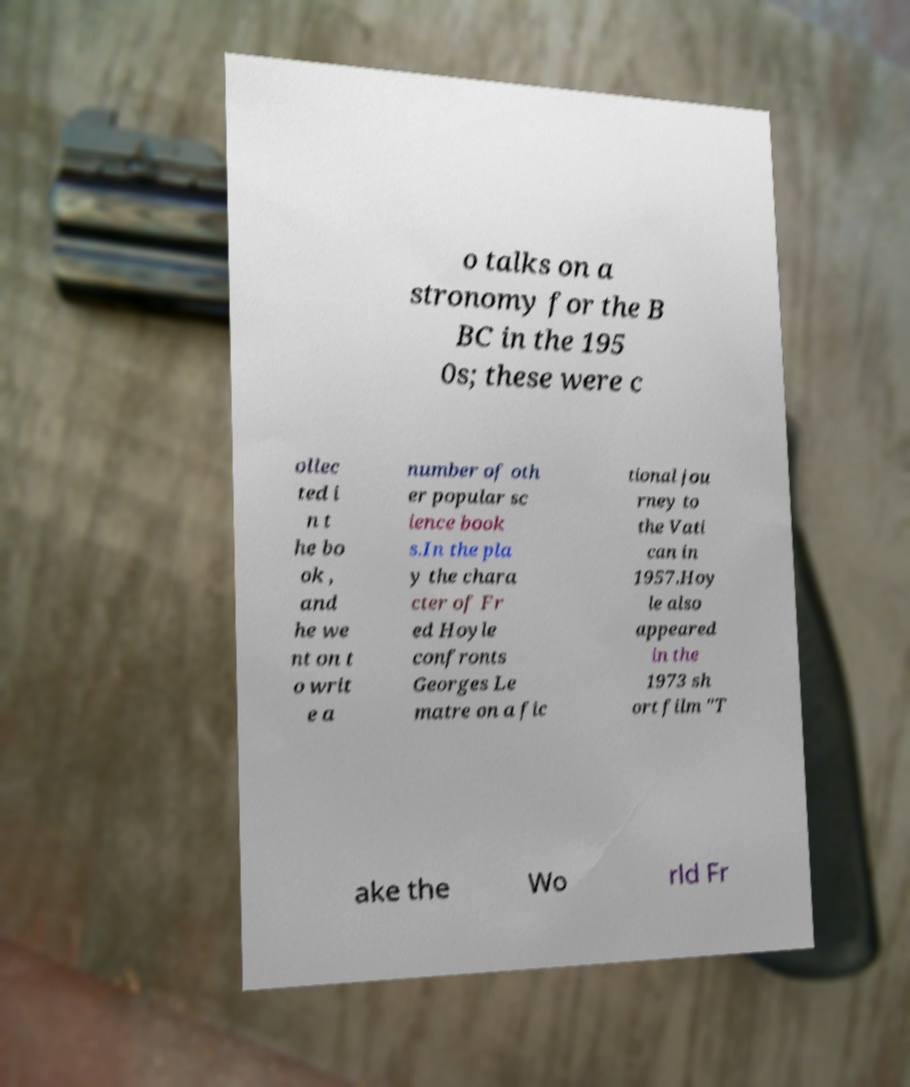Please identify and transcribe the text found in this image. o talks on a stronomy for the B BC in the 195 0s; these were c ollec ted i n t he bo ok , and he we nt on t o writ e a number of oth er popular sc ience book s.In the pla y the chara cter of Fr ed Hoyle confronts Georges Le matre on a fic tional jou rney to the Vati can in 1957.Hoy le also appeared in the 1973 sh ort film "T ake the Wo rld Fr 